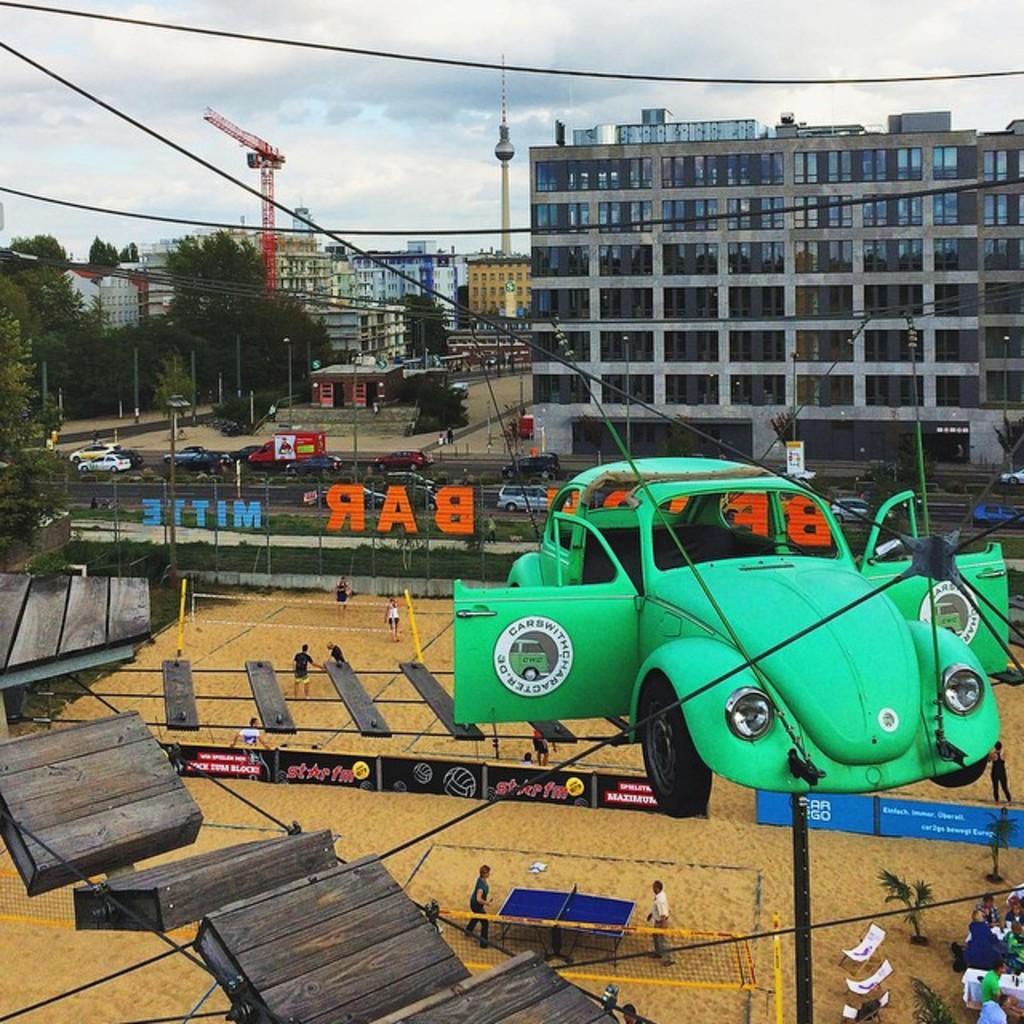In one or two sentences, can you explain what this image depicts? In the center of the image we can see a fun ride. At the bottom there are people and there is a table tennis. We can see a net. In the background there are buildings, trees, ropes and sky. We can see a crane. There are poles and cars. On the right there are chairs and we can see people sitting. 